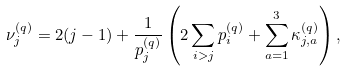<formula> <loc_0><loc_0><loc_500><loc_500>\nu _ { j } ^ { ( q ) } = 2 ( j - 1 ) + \frac { 1 } { p _ { j } ^ { ( q ) } } \left ( 2 \sum _ { i > j } p _ { i } ^ { ( q ) } + \sum _ { a = 1 } ^ { 3 } \kappa _ { j , a } ^ { ( q ) } \right ) ,</formula> 